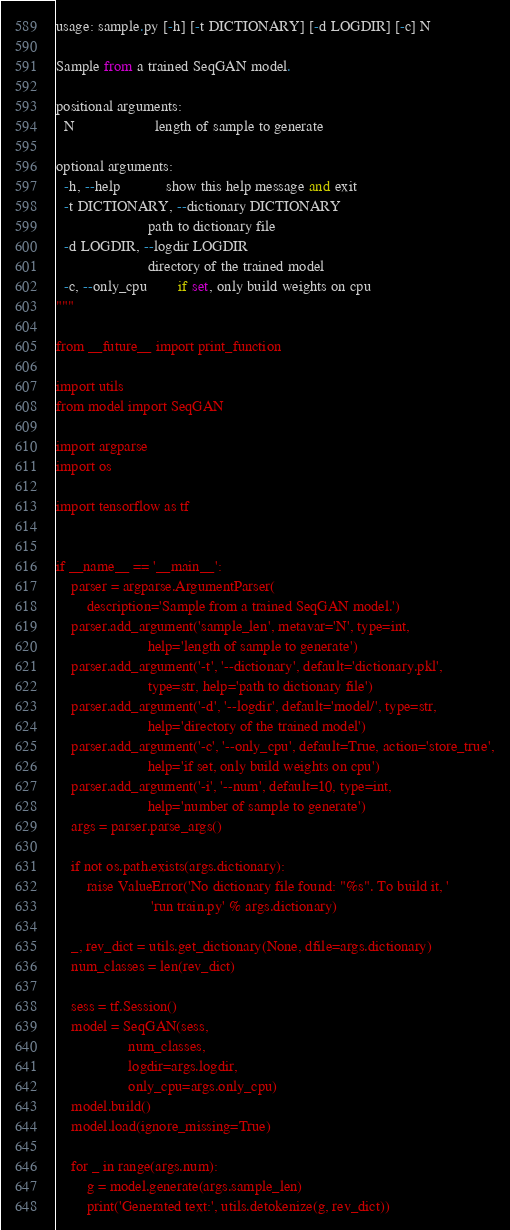Convert code to text. <code><loc_0><loc_0><loc_500><loc_500><_Python_>
usage: sample.py [-h] [-t DICTIONARY] [-d LOGDIR] [-c] N

Sample from a trained SeqGAN model.

positional arguments:
  N                     length of sample to generate

optional arguments:
  -h, --help            show this help message and exit
  -t DICTIONARY, --dictionary DICTIONARY
                        path to dictionary file
  -d LOGDIR, --logdir LOGDIR
                        directory of the trained model
  -c, --only_cpu        if set, only build weights on cpu
"""

from __future__ import print_function

import utils
from model import SeqGAN

import argparse
import os

import tensorflow as tf


if __name__ == '__main__':
    parser = argparse.ArgumentParser(
        description='Sample from a trained SeqGAN model.')
    parser.add_argument('sample_len', metavar='N', type=int,
                        help='length of sample to generate')
    parser.add_argument('-t', '--dictionary', default='dictionary.pkl',
                        type=str, help='path to dictionary file')
    parser.add_argument('-d', '--logdir', default='model/', type=str,
                        help='directory of the trained model')
    parser.add_argument('-c', '--only_cpu', default=True, action='store_true',
                        help='if set, only build weights on cpu')
    parser.add_argument('-i', '--num', default=10, type=int,
                        help='number of sample to generate')
    args = parser.parse_args()

    if not os.path.exists(args.dictionary):
        raise ValueError('No dictionary file found: "%s". To build it, '
                         'run train.py' % args.dictionary)

    _, rev_dict = utils.get_dictionary(None, dfile=args.dictionary)
    num_classes = len(rev_dict)

    sess = tf.Session()
    model = SeqGAN(sess,
                   num_classes,
                   logdir=args.logdir,
                   only_cpu=args.only_cpu)
    model.build()
    model.load(ignore_missing=True)

    for _ in range(args.num):
        g = model.generate(args.sample_len)
        print('Generated text:', utils.detokenize(g, rev_dict))
</code> 